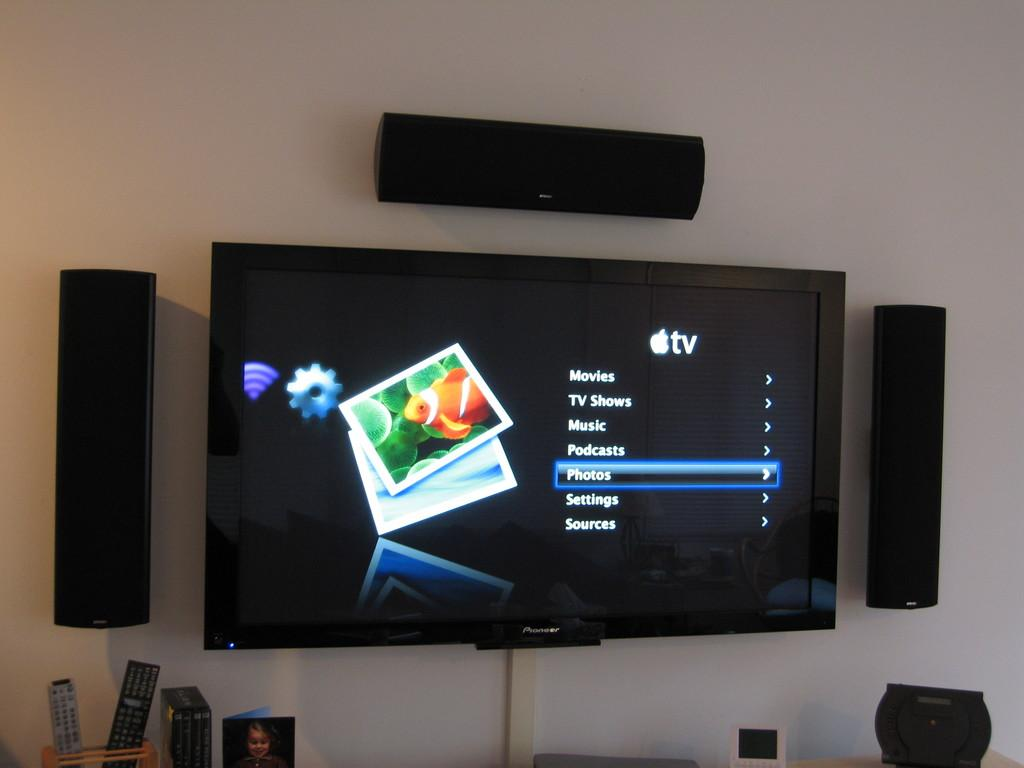<image>
Provide a brief description of the given image. A TV that says Movies, TV Shows, and Music is surrounded by speakers. 